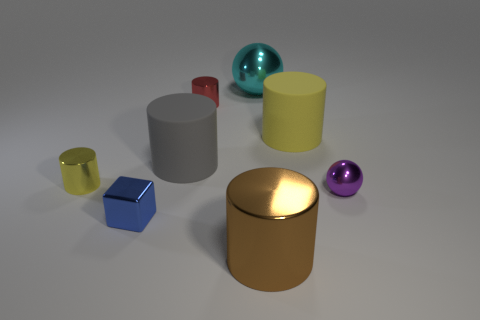Which object appears to be the largest? The object that appears to be the largest in the image is the gold cylinder placed in the foreground. 